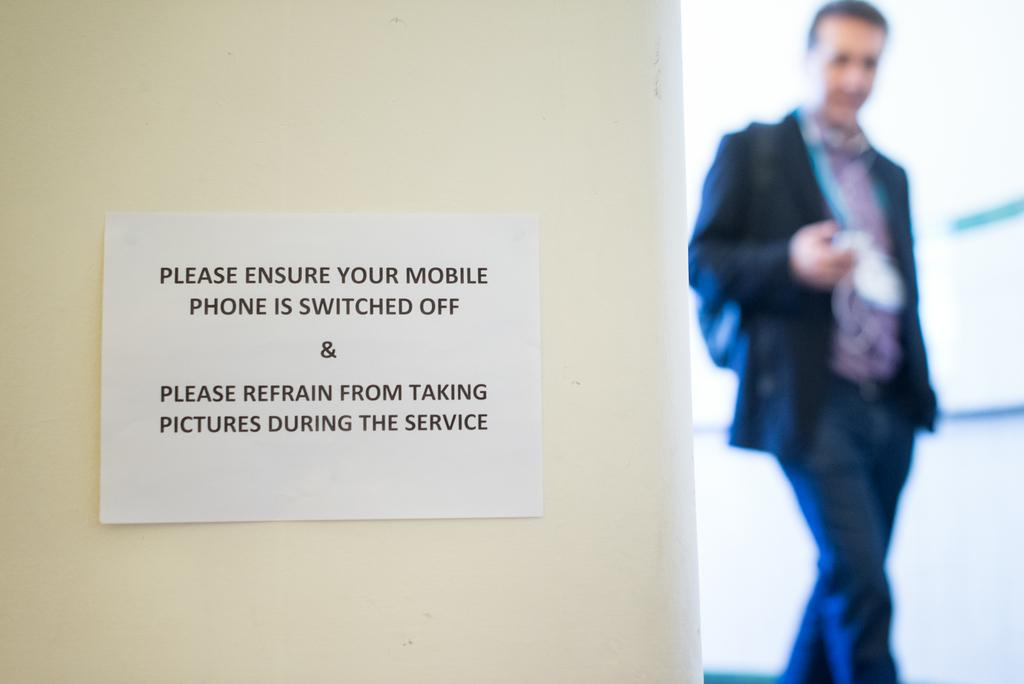What is attached to the wall on the left side of the image? There is a paper stuck to the wall on the left side of the image. What can be seen on the right side of the image? There is a person standing on the right side of the image. What type of rock is being used for destruction in the image? There is no rock or destruction present in the image. Can you provide an example of a similar situation to the one depicted in the image? It is not possible to provide an example of a similar situation based on the information given in the image. 